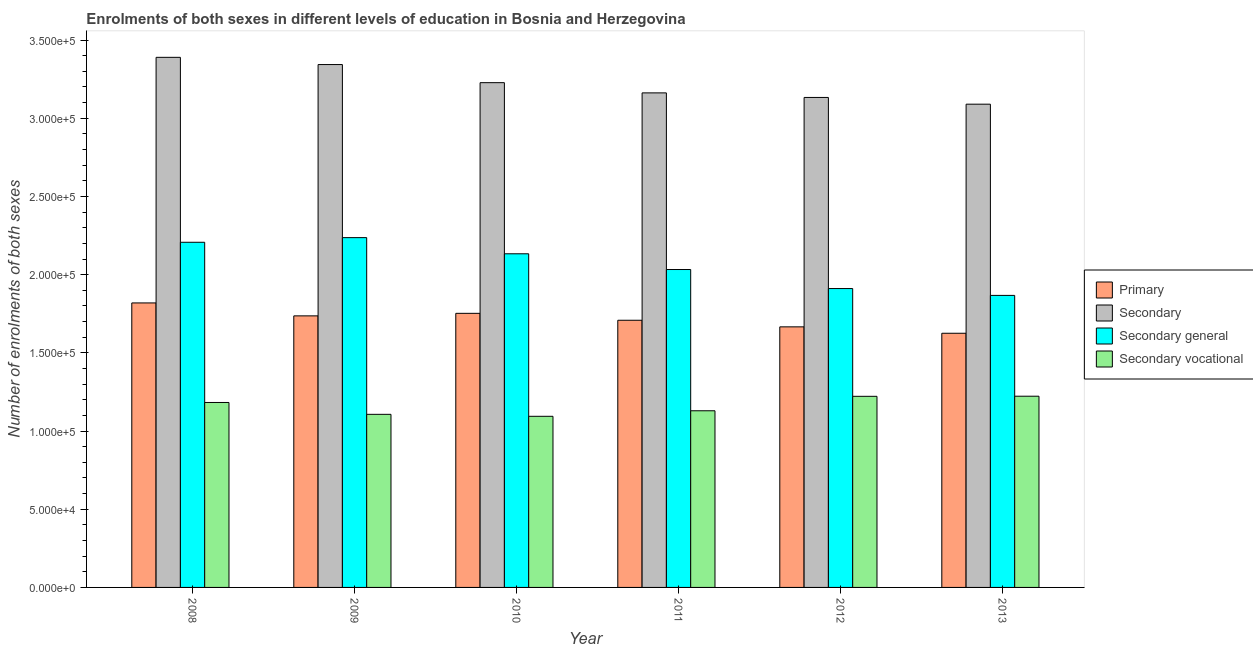How many different coloured bars are there?
Ensure brevity in your answer.  4. How many groups of bars are there?
Your response must be concise. 6. Are the number of bars per tick equal to the number of legend labels?
Offer a very short reply. Yes. Are the number of bars on each tick of the X-axis equal?
Offer a very short reply. Yes. How many bars are there on the 4th tick from the left?
Give a very brief answer. 4. What is the label of the 4th group of bars from the left?
Your answer should be compact. 2011. In how many cases, is the number of bars for a given year not equal to the number of legend labels?
Your response must be concise. 0. What is the number of enrolments in secondary general education in 2009?
Provide a short and direct response. 2.24e+05. Across all years, what is the maximum number of enrolments in primary education?
Offer a very short reply. 1.82e+05. Across all years, what is the minimum number of enrolments in secondary vocational education?
Provide a short and direct response. 1.09e+05. In which year was the number of enrolments in secondary education maximum?
Offer a terse response. 2008. In which year was the number of enrolments in primary education minimum?
Ensure brevity in your answer.  2013. What is the total number of enrolments in secondary general education in the graph?
Offer a very short reply. 1.24e+06. What is the difference between the number of enrolments in secondary education in 2008 and that in 2009?
Ensure brevity in your answer.  4616. What is the difference between the number of enrolments in secondary education in 2012 and the number of enrolments in primary education in 2009?
Offer a very short reply. -2.10e+04. What is the average number of enrolments in secondary vocational education per year?
Keep it short and to the point. 1.16e+05. In the year 2011, what is the difference between the number of enrolments in secondary general education and number of enrolments in primary education?
Your answer should be compact. 0. In how many years, is the number of enrolments in secondary vocational education greater than 260000?
Your answer should be compact. 0. What is the ratio of the number of enrolments in secondary vocational education in 2008 to that in 2010?
Keep it short and to the point. 1.08. Is the number of enrolments in secondary vocational education in 2008 less than that in 2013?
Keep it short and to the point. Yes. Is the difference between the number of enrolments in secondary general education in 2010 and 2013 greater than the difference between the number of enrolments in primary education in 2010 and 2013?
Your response must be concise. No. What is the difference between the highest and the second highest number of enrolments in primary education?
Offer a very short reply. 6646. What is the difference between the highest and the lowest number of enrolments in secondary vocational education?
Your answer should be very brief. 1.28e+04. Is it the case that in every year, the sum of the number of enrolments in secondary education and number of enrolments in secondary general education is greater than the sum of number of enrolments in primary education and number of enrolments in secondary vocational education?
Make the answer very short. Yes. What does the 2nd bar from the left in 2009 represents?
Offer a terse response. Secondary. What does the 1st bar from the right in 2010 represents?
Provide a succinct answer. Secondary vocational. Is it the case that in every year, the sum of the number of enrolments in primary education and number of enrolments in secondary education is greater than the number of enrolments in secondary general education?
Make the answer very short. Yes. How many years are there in the graph?
Your answer should be compact. 6. Does the graph contain grids?
Make the answer very short. No. How many legend labels are there?
Give a very brief answer. 4. What is the title of the graph?
Provide a short and direct response. Enrolments of both sexes in different levels of education in Bosnia and Herzegovina. Does "France" appear as one of the legend labels in the graph?
Your answer should be compact. No. What is the label or title of the Y-axis?
Keep it short and to the point. Number of enrolments of both sexes. What is the Number of enrolments of both sexes in Primary in 2008?
Offer a very short reply. 1.82e+05. What is the Number of enrolments of both sexes of Secondary in 2008?
Offer a very short reply. 3.39e+05. What is the Number of enrolments of both sexes of Secondary general in 2008?
Make the answer very short. 2.21e+05. What is the Number of enrolments of both sexes in Secondary vocational in 2008?
Your answer should be compact. 1.18e+05. What is the Number of enrolments of both sexes in Primary in 2009?
Provide a succinct answer. 1.74e+05. What is the Number of enrolments of both sexes in Secondary in 2009?
Your answer should be very brief. 3.34e+05. What is the Number of enrolments of both sexes in Secondary general in 2009?
Make the answer very short. 2.24e+05. What is the Number of enrolments of both sexes of Secondary vocational in 2009?
Your response must be concise. 1.11e+05. What is the Number of enrolments of both sexes of Primary in 2010?
Make the answer very short. 1.75e+05. What is the Number of enrolments of both sexes in Secondary in 2010?
Your answer should be compact. 3.23e+05. What is the Number of enrolments of both sexes in Secondary general in 2010?
Ensure brevity in your answer.  2.13e+05. What is the Number of enrolments of both sexes of Secondary vocational in 2010?
Make the answer very short. 1.09e+05. What is the Number of enrolments of both sexes in Primary in 2011?
Give a very brief answer. 1.71e+05. What is the Number of enrolments of both sexes of Secondary in 2011?
Provide a short and direct response. 3.16e+05. What is the Number of enrolments of both sexes in Secondary general in 2011?
Offer a terse response. 2.03e+05. What is the Number of enrolments of both sexes in Secondary vocational in 2011?
Give a very brief answer. 1.13e+05. What is the Number of enrolments of both sexes in Primary in 2012?
Give a very brief answer. 1.67e+05. What is the Number of enrolments of both sexes of Secondary in 2012?
Provide a succinct answer. 3.13e+05. What is the Number of enrolments of both sexes of Secondary general in 2012?
Keep it short and to the point. 1.91e+05. What is the Number of enrolments of both sexes of Secondary vocational in 2012?
Offer a very short reply. 1.22e+05. What is the Number of enrolments of both sexes in Primary in 2013?
Make the answer very short. 1.63e+05. What is the Number of enrolments of both sexes in Secondary in 2013?
Your answer should be very brief. 3.09e+05. What is the Number of enrolments of both sexes in Secondary general in 2013?
Provide a short and direct response. 1.87e+05. What is the Number of enrolments of both sexes in Secondary vocational in 2013?
Your answer should be very brief. 1.22e+05. Across all years, what is the maximum Number of enrolments of both sexes in Primary?
Offer a terse response. 1.82e+05. Across all years, what is the maximum Number of enrolments of both sexes of Secondary?
Keep it short and to the point. 3.39e+05. Across all years, what is the maximum Number of enrolments of both sexes of Secondary general?
Make the answer very short. 2.24e+05. Across all years, what is the maximum Number of enrolments of both sexes of Secondary vocational?
Your answer should be compact. 1.22e+05. Across all years, what is the minimum Number of enrolments of both sexes in Primary?
Keep it short and to the point. 1.63e+05. Across all years, what is the minimum Number of enrolments of both sexes of Secondary?
Give a very brief answer. 3.09e+05. Across all years, what is the minimum Number of enrolments of both sexes of Secondary general?
Offer a terse response. 1.87e+05. Across all years, what is the minimum Number of enrolments of both sexes of Secondary vocational?
Offer a very short reply. 1.09e+05. What is the total Number of enrolments of both sexes of Primary in the graph?
Provide a short and direct response. 1.03e+06. What is the total Number of enrolments of both sexes in Secondary in the graph?
Your answer should be very brief. 1.93e+06. What is the total Number of enrolments of both sexes in Secondary general in the graph?
Offer a terse response. 1.24e+06. What is the total Number of enrolments of both sexes in Secondary vocational in the graph?
Give a very brief answer. 6.96e+05. What is the difference between the Number of enrolments of both sexes in Primary in 2008 and that in 2009?
Give a very brief answer. 8270. What is the difference between the Number of enrolments of both sexes of Secondary in 2008 and that in 2009?
Provide a succinct answer. 4616. What is the difference between the Number of enrolments of both sexes of Secondary general in 2008 and that in 2009?
Make the answer very short. -2965. What is the difference between the Number of enrolments of both sexes of Secondary vocational in 2008 and that in 2009?
Offer a very short reply. 7581. What is the difference between the Number of enrolments of both sexes in Primary in 2008 and that in 2010?
Your answer should be compact. 6646. What is the difference between the Number of enrolments of both sexes of Secondary in 2008 and that in 2010?
Ensure brevity in your answer.  1.62e+04. What is the difference between the Number of enrolments of both sexes in Secondary general in 2008 and that in 2010?
Offer a very short reply. 7367. What is the difference between the Number of enrolments of both sexes of Secondary vocational in 2008 and that in 2010?
Provide a succinct answer. 8838. What is the difference between the Number of enrolments of both sexes in Primary in 2008 and that in 2011?
Ensure brevity in your answer.  1.11e+04. What is the difference between the Number of enrolments of both sexes in Secondary in 2008 and that in 2011?
Provide a short and direct response. 2.27e+04. What is the difference between the Number of enrolments of both sexes in Secondary general in 2008 and that in 2011?
Provide a short and direct response. 1.74e+04. What is the difference between the Number of enrolments of both sexes in Secondary vocational in 2008 and that in 2011?
Make the answer very short. 5300. What is the difference between the Number of enrolments of both sexes in Primary in 2008 and that in 2012?
Make the answer very short. 1.53e+04. What is the difference between the Number of enrolments of both sexes in Secondary in 2008 and that in 2012?
Provide a short and direct response. 2.56e+04. What is the difference between the Number of enrolments of both sexes of Secondary general in 2008 and that in 2012?
Offer a terse response. 2.96e+04. What is the difference between the Number of enrolments of both sexes of Secondary vocational in 2008 and that in 2012?
Offer a very short reply. -3941. What is the difference between the Number of enrolments of both sexes of Primary in 2008 and that in 2013?
Keep it short and to the point. 1.94e+04. What is the difference between the Number of enrolments of both sexes in Secondary in 2008 and that in 2013?
Provide a short and direct response. 3.00e+04. What is the difference between the Number of enrolments of both sexes in Secondary general in 2008 and that in 2013?
Your response must be concise. 3.40e+04. What is the difference between the Number of enrolments of both sexes in Secondary vocational in 2008 and that in 2013?
Provide a succinct answer. -4011. What is the difference between the Number of enrolments of both sexes in Primary in 2009 and that in 2010?
Your answer should be compact. -1624. What is the difference between the Number of enrolments of both sexes of Secondary in 2009 and that in 2010?
Provide a short and direct response. 1.16e+04. What is the difference between the Number of enrolments of both sexes of Secondary general in 2009 and that in 2010?
Offer a very short reply. 1.03e+04. What is the difference between the Number of enrolments of both sexes of Secondary vocational in 2009 and that in 2010?
Your answer should be compact. 1257. What is the difference between the Number of enrolments of both sexes of Primary in 2009 and that in 2011?
Keep it short and to the point. 2805. What is the difference between the Number of enrolments of both sexes in Secondary in 2009 and that in 2011?
Your answer should be very brief. 1.81e+04. What is the difference between the Number of enrolments of both sexes in Secondary general in 2009 and that in 2011?
Ensure brevity in your answer.  2.04e+04. What is the difference between the Number of enrolments of both sexes of Secondary vocational in 2009 and that in 2011?
Make the answer very short. -2281. What is the difference between the Number of enrolments of both sexes in Primary in 2009 and that in 2012?
Your answer should be very brief. 7027. What is the difference between the Number of enrolments of both sexes in Secondary in 2009 and that in 2012?
Give a very brief answer. 2.10e+04. What is the difference between the Number of enrolments of both sexes in Secondary general in 2009 and that in 2012?
Give a very brief answer. 3.26e+04. What is the difference between the Number of enrolments of both sexes in Secondary vocational in 2009 and that in 2012?
Provide a short and direct response. -1.15e+04. What is the difference between the Number of enrolments of both sexes of Primary in 2009 and that in 2013?
Your answer should be very brief. 1.11e+04. What is the difference between the Number of enrolments of both sexes of Secondary in 2009 and that in 2013?
Ensure brevity in your answer.  2.53e+04. What is the difference between the Number of enrolments of both sexes in Secondary general in 2009 and that in 2013?
Give a very brief answer. 3.69e+04. What is the difference between the Number of enrolments of both sexes of Secondary vocational in 2009 and that in 2013?
Give a very brief answer. -1.16e+04. What is the difference between the Number of enrolments of both sexes in Primary in 2010 and that in 2011?
Offer a very short reply. 4429. What is the difference between the Number of enrolments of both sexes of Secondary in 2010 and that in 2011?
Make the answer very short. 6525. What is the difference between the Number of enrolments of both sexes in Secondary general in 2010 and that in 2011?
Provide a succinct answer. 1.01e+04. What is the difference between the Number of enrolments of both sexes of Secondary vocational in 2010 and that in 2011?
Make the answer very short. -3538. What is the difference between the Number of enrolments of both sexes in Primary in 2010 and that in 2012?
Ensure brevity in your answer.  8651. What is the difference between the Number of enrolments of both sexes in Secondary in 2010 and that in 2012?
Give a very brief answer. 9445. What is the difference between the Number of enrolments of both sexes of Secondary general in 2010 and that in 2012?
Provide a succinct answer. 2.22e+04. What is the difference between the Number of enrolments of both sexes of Secondary vocational in 2010 and that in 2012?
Provide a succinct answer. -1.28e+04. What is the difference between the Number of enrolments of both sexes in Primary in 2010 and that in 2013?
Offer a very short reply. 1.27e+04. What is the difference between the Number of enrolments of both sexes of Secondary in 2010 and that in 2013?
Your answer should be compact. 1.38e+04. What is the difference between the Number of enrolments of both sexes in Secondary general in 2010 and that in 2013?
Your response must be concise. 2.66e+04. What is the difference between the Number of enrolments of both sexes in Secondary vocational in 2010 and that in 2013?
Make the answer very short. -1.28e+04. What is the difference between the Number of enrolments of both sexes of Primary in 2011 and that in 2012?
Give a very brief answer. 4222. What is the difference between the Number of enrolments of both sexes in Secondary in 2011 and that in 2012?
Provide a succinct answer. 2920. What is the difference between the Number of enrolments of both sexes in Secondary general in 2011 and that in 2012?
Give a very brief answer. 1.22e+04. What is the difference between the Number of enrolments of both sexes in Secondary vocational in 2011 and that in 2012?
Provide a succinct answer. -9241. What is the difference between the Number of enrolments of both sexes in Primary in 2011 and that in 2013?
Keep it short and to the point. 8314. What is the difference between the Number of enrolments of both sexes of Secondary in 2011 and that in 2013?
Your response must be concise. 7226. What is the difference between the Number of enrolments of both sexes in Secondary general in 2011 and that in 2013?
Provide a short and direct response. 1.65e+04. What is the difference between the Number of enrolments of both sexes in Secondary vocational in 2011 and that in 2013?
Provide a short and direct response. -9311. What is the difference between the Number of enrolments of both sexes of Primary in 2012 and that in 2013?
Make the answer very short. 4092. What is the difference between the Number of enrolments of both sexes in Secondary in 2012 and that in 2013?
Offer a very short reply. 4306. What is the difference between the Number of enrolments of both sexes in Secondary general in 2012 and that in 2013?
Your answer should be compact. 4376. What is the difference between the Number of enrolments of both sexes in Secondary vocational in 2012 and that in 2013?
Provide a succinct answer. -70. What is the difference between the Number of enrolments of both sexes in Primary in 2008 and the Number of enrolments of both sexes in Secondary in 2009?
Keep it short and to the point. -1.52e+05. What is the difference between the Number of enrolments of both sexes of Primary in 2008 and the Number of enrolments of both sexes of Secondary general in 2009?
Your answer should be compact. -4.18e+04. What is the difference between the Number of enrolments of both sexes in Primary in 2008 and the Number of enrolments of both sexes in Secondary vocational in 2009?
Offer a very short reply. 7.12e+04. What is the difference between the Number of enrolments of both sexes of Secondary in 2008 and the Number of enrolments of both sexes of Secondary general in 2009?
Your response must be concise. 1.15e+05. What is the difference between the Number of enrolments of both sexes of Secondary in 2008 and the Number of enrolments of both sexes of Secondary vocational in 2009?
Your response must be concise. 2.28e+05. What is the difference between the Number of enrolments of both sexes in Secondary general in 2008 and the Number of enrolments of both sexes in Secondary vocational in 2009?
Provide a short and direct response. 1.10e+05. What is the difference between the Number of enrolments of both sexes of Primary in 2008 and the Number of enrolments of both sexes of Secondary in 2010?
Your response must be concise. -1.41e+05. What is the difference between the Number of enrolments of both sexes of Primary in 2008 and the Number of enrolments of both sexes of Secondary general in 2010?
Offer a very short reply. -3.14e+04. What is the difference between the Number of enrolments of both sexes in Primary in 2008 and the Number of enrolments of both sexes in Secondary vocational in 2010?
Give a very brief answer. 7.25e+04. What is the difference between the Number of enrolments of both sexes of Secondary in 2008 and the Number of enrolments of both sexes of Secondary general in 2010?
Your response must be concise. 1.26e+05. What is the difference between the Number of enrolments of both sexes of Secondary in 2008 and the Number of enrolments of both sexes of Secondary vocational in 2010?
Give a very brief answer. 2.30e+05. What is the difference between the Number of enrolments of both sexes of Secondary general in 2008 and the Number of enrolments of both sexes of Secondary vocational in 2010?
Ensure brevity in your answer.  1.11e+05. What is the difference between the Number of enrolments of both sexes in Primary in 2008 and the Number of enrolments of both sexes in Secondary in 2011?
Your response must be concise. -1.34e+05. What is the difference between the Number of enrolments of both sexes in Primary in 2008 and the Number of enrolments of both sexes in Secondary general in 2011?
Your answer should be compact. -2.14e+04. What is the difference between the Number of enrolments of both sexes in Primary in 2008 and the Number of enrolments of both sexes in Secondary vocational in 2011?
Ensure brevity in your answer.  6.90e+04. What is the difference between the Number of enrolments of both sexes of Secondary in 2008 and the Number of enrolments of both sexes of Secondary general in 2011?
Ensure brevity in your answer.  1.36e+05. What is the difference between the Number of enrolments of both sexes in Secondary in 2008 and the Number of enrolments of both sexes in Secondary vocational in 2011?
Your answer should be compact. 2.26e+05. What is the difference between the Number of enrolments of both sexes of Secondary general in 2008 and the Number of enrolments of both sexes of Secondary vocational in 2011?
Give a very brief answer. 1.08e+05. What is the difference between the Number of enrolments of both sexes in Primary in 2008 and the Number of enrolments of both sexes in Secondary in 2012?
Make the answer very short. -1.31e+05. What is the difference between the Number of enrolments of both sexes of Primary in 2008 and the Number of enrolments of both sexes of Secondary general in 2012?
Keep it short and to the point. -9201. What is the difference between the Number of enrolments of both sexes of Primary in 2008 and the Number of enrolments of both sexes of Secondary vocational in 2012?
Your response must be concise. 5.97e+04. What is the difference between the Number of enrolments of both sexes of Secondary in 2008 and the Number of enrolments of both sexes of Secondary general in 2012?
Keep it short and to the point. 1.48e+05. What is the difference between the Number of enrolments of both sexes in Secondary in 2008 and the Number of enrolments of both sexes in Secondary vocational in 2012?
Offer a terse response. 2.17e+05. What is the difference between the Number of enrolments of both sexes of Secondary general in 2008 and the Number of enrolments of both sexes of Secondary vocational in 2012?
Offer a terse response. 9.85e+04. What is the difference between the Number of enrolments of both sexes in Primary in 2008 and the Number of enrolments of both sexes in Secondary in 2013?
Your answer should be compact. -1.27e+05. What is the difference between the Number of enrolments of both sexes in Primary in 2008 and the Number of enrolments of both sexes in Secondary general in 2013?
Provide a short and direct response. -4825. What is the difference between the Number of enrolments of both sexes of Primary in 2008 and the Number of enrolments of both sexes of Secondary vocational in 2013?
Provide a succinct answer. 5.96e+04. What is the difference between the Number of enrolments of both sexes of Secondary in 2008 and the Number of enrolments of both sexes of Secondary general in 2013?
Provide a succinct answer. 1.52e+05. What is the difference between the Number of enrolments of both sexes of Secondary in 2008 and the Number of enrolments of both sexes of Secondary vocational in 2013?
Offer a very short reply. 2.17e+05. What is the difference between the Number of enrolments of both sexes in Secondary general in 2008 and the Number of enrolments of both sexes in Secondary vocational in 2013?
Ensure brevity in your answer.  9.84e+04. What is the difference between the Number of enrolments of both sexes of Primary in 2009 and the Number of enrolments of both sexes of Secondary in 2010?
Ensure brevity in your answer.  -1.49e+05. What is the difference between the Number of enrolments of both sexes in Primary in 2009 and the Number of enrolments of both sexes in Secondary general in 2010?
Offer a terse response. -3.97e+04. What is the difference between the Number of enrolments of both sexes in Primary in 2009 and the Number of enrolments of both sexes in Secondary vocational in 2010?
Your answer should be compact. 6.42e+04. What is the difference between the Number of enrolments of both sexes of Secondary in 2009 and the Number of enrolments of both sexes of Secondary general in 2010?
Provide a succinct answer. 1.21e+05. What is the difference between the Number of enrolments of both sexes of Secondary in 2009 and the Number of enrolments of both sexes of Secondary vocational in 2010?
Provide a short and direct response. 2.25e+05. What is the difference between the Number of enrolments of both sexes in Secondary general in 2009 and the Number of enrolments of both sexes in Secondary vocational in 2010?
Make the answer very short. 1.14e+05. What is the difference between the Number of enrolments of both sexes in Primary in 2009 and the Number of enrolments of both sexes in Secondary in 2011?
Give a very brief answer. -1.43e+05. What is the difference between the Number of enrolments of both sexes in Primary in 2009 and the Number of enrolments of both sexes in Secondary general in 2011?
Make the answer very short. -2.96e+04. What is the difference between the Number of enrolments of both sexes of Primary in 2009 and the Number of enrolments of both sexes of Secondary vocational in 2011?
Provide a short and direct response. 6.07e+04. What is the difference between the Number of enrolments of both sexes in Secondary in 2009 and the Number of enrolments of both sexes in Secondary general in 2011?
Provide a succinct answer. 1.31e+05. What is the difference between the Number of enrolments of both sexes of Secondary in 2009 and the Number of enrolments of both sexes of Secondary vocational in 2011?
Provide a succinct answer. 2.21e+05. What is the difference between the Number of enrolments of both sexes in Secondary general in 2009 and the Number of enrolments of both sexes in Secondary vocational in 2011?
Your response must be concise. 1.11e+05. What is the difference between the Number of enrolments of both sexes of Primary in 2009 and the Number of enrolments of both sexes of Secondary in 2012?
Keep it short and to the point. -1.40e+05. What is the difference between the Number of enrolments of both sexes in Primary in 2009 and the Number of enrolments of both sexes in Secondary general in 2012?
Offer a terse response. -1.75e+04. What is the difference between the Number of enrolments of both sexes in Primary in 2009 and the Number of enrolments of both sexes in Secondary vocational in 2012?
Provide a short and direct response. 5.14e+04. What is the difference between the Number of enrolments of both sexes in Secondary in 2009 and the Number of enrolments of both sexes in Secondary general in 2012?
Your response must be concise. 1.43e+05. What is the difference between the Number of enrolments of both sexes in Secondary in 2009 and the Number of enrolments of both sexes in Secondary vocational in 2012?
Your response must be concise. 2.12e+05. What is the difference between the Number of enrolments of both sexes of Secondary general in 2009 and the Number of enrolments of both sexes of Secondary vocational in 2012?
Ensure brevity in your answer.  1.01e+05. What is the difference between the Number of enrolments of both sexes in Primary in 2009 and the Number of enrolments of both sexes in Secondary in 2013?
Your answer should be compact. -1.35e+05. What is the difference between the Number of enrolments of both sexes of Primary in 2009 and the Number of enrolments of both sexes of Secondary general in 2013?
Make the answer very short. -1.31e+04. What is the difference between the Number of enrolments of both sexes in Primary in 2009 and the Number of enrolments of both sexes in Secondary vocational in 2013?
Give a very brief answer. 5.14e+04. What is the difference between the Number of enrolments of both sexes in Secondary in 2009 and the Number of enrolments of both sexes in Secondary general in 2013?
Make the answer very short. 1.48e+05. What is the difference between the Number of enrolments of both sexes in Secondary in 2009 and the Number of enrolments of both sexes in Secondary vocational in 2013?
Give a very brief answer. 2.12e+05. What is the difference between the Number of enrolments of both sexes in Secondary general in 2009 and the Number of enrolments of both sexes in Secondary vocational in 2013?
Your answer should be very brief. 1.01e+05. What is the difference between the Number of enrolments of both sexes in Primary in 2010 and the Number of enrolments of both sexes in Secondary in 2011?
Make the answer very short. -1.41e+05. What is the difference between the Number of enrolments of both sexes in Primary in 2010 and the Number of enrolments of both sexes in Secondary general in 2011?
Give a very brief answer. -2.80e+04. What is the difference between the Number of enrolments of both sexes of Primary in 2010 and the Number of enrolments of both sexes of Secondary vocational in 2011?
Make the answer very short. 6.23e+04. What is the difference between the Number of enrolments of both sexes in Secondary in 2010 and the Number of enrolments of both sexes in Secondary general in 2011?
Your answer should be very brief. 1.19e+05. What is the difference between the Number of enrolments of both sexes in Secondary in 2010 and the Number of enrolments of both sexes in Secondary vocational in 2011?
Your answer should be compact. 2.10e+05. What is the difference between the Number of enrolments of both sexes in Secondary general in 2010 and the Number of enrolments of both sexes in Secondary vocational in 2011?
Your response must be concise. 1.00e+05. What is the difference between the Number of enrolments of both sexes of Primary in 2010 and the Number of enrolments of both sexes of Secondary in 2012?
Keep it short and to the point. -1.38e+05. What is the difference between the Number of enrolments of both sexes of Primary in 2010 and the Number of enrolments of both sexes of Secondary general in 2012?
Your answer should be compact. -1.58e+04. What is the difference between the Number of enrolments of both sexes in Primary in 2010 and the Number of enrolments of both sexes in Secondary vocational in 2012?
Keep it short and to the point. 5.31e+04. What is the difference between the Number of enrolments of both sexes in Secondary in 2010 and the Number of enrolments of both sexes in Secondary general in 2012?
Make the answer very short. 1.32e+05. What is the difference between the Number of enrolments of both sexes of Secondary in 2010 and the Number of enrolments of both sexes of Secondary vocational in 2012?
Provide a succinct answer. 2.01e+05. What is the difference between the Number of enrolments of both sexes of Secondary general in 2010 and the Number of enrolments of both sexes of Secondary vocational in 2012?
Ensure brevity in your answer.  9.11e+04. What is the difference between the Number of enrolments of both sexes in Primary in 2010 and the Number of enrolments of both sexes in Secondary in 2013?
Ensure brevity in your answer.  -1.34e+05. What is the difference between the Number of enrolments of both sexes in Primary in 2010 and the Number of enrolments of both sexes in Secondary general in 2013?
Your answer should be compact. -1.15e+04. What is the difference between the Number of enrolments of both sexes in Primary in 2010 and the Number of enrolments of both sexes in Secondary vocational in 2013?
Keep it short and to the point. 5.30e+04. What is the difference between the Number of enrolments of both sexes of Secondary in 2010 and the Number of enrolments of both sexes of Secondary general in 2013?
Make the answer very short. 1.36e+05. What is the difference between the Number of enrolments of both sexes of Secondary in 2010 and the Number of enrolments of both sexes of Secondary vocational in 2013?
Provide a succinct answer. 2.00e+05. What is the difference between the Number of enrolments of both sexes of Secondary general in 2010 and the Number of enrolments of both sexes of Secondary vocational in 2013?
Make the answer very short. 9.11e+04. What is the difference between the Number of enrolments of both sexes of Primary in 2011 and the Number of enrolments of both sexes of Secondary in 2012?
Your answer should be compact. -1.42e+05. What is the difference between the Number of enrolments of both sexes of Primary in 2011 and the Number of enrolments of both sexes of Secondary general in 2012?
Provide a short and direct response. -2.03e+04. What is the difference between the Number of enrolments of both sexes of Primary in 2011 and the Number of enrolments of both sexes of Secondary vocational in 2012?
Provide a succinct answer. 4.86e+04. What is the difference between the Number of enrolments of both sexes in Secondary in 2011 and the Number of enrolments of both sexes in Secondary general in 2012?
Provide a short and direct response. 1.25e+05. What is the difference between the Number of enrolments of both sexes of Secondary in 2011 and the Number of enrolments of both sexes of Secondary vocational in 2012?
Provide a short and direct response. 1.94e+05. What is the difference between the Number of enrolments of both sexes in Secondary general in 2011 and the Number of enrolments of both sexes in Secondary vocational in 2012?
Your answer should be compact. 8.11e+04. What is the difference between the Number of enrolments of both sexes in Primary in 2011 and the Number of enrolments of both sexes in Secondary in 2013?
Offer a terse response. -1.38e+05. What is the difference between the Number of enrolments of both sexes of Primary in 2011 and the Number of enrolments of both sexes of Secondary general in 2013?
Provide a succinct answer. -1.59e+04. What is the difference between the Number of enrolments of both sexes in Primary in 2011 and the Number of enrolments of both sexes in Secondary vocational in 2013?
Make the answer very short. 4.86e+04. What is the difference between the Number of enrolments of both sexes in Secondary in 2011 and the Number of enrolments of both sexes in Secondary general in 2013?
Give a very brief answer. 1.29e+05. What is the difference between the Number of enrolments of both sexes of Secondary in 2011 and the Number of enrolments of both sexes of Secondary vocational in 2013?
Provide a succinct answer. 1.94e+05. What is the difference between the Number of enrolments of both sexes of Secondary general in 2011 and the Number of enrolments of both sexes of Secondary vocational in 2013?
Keep it short and to the point. 8.10e+04. What is the difference between the Number of enrolments of both sexes of Primary in 2012 and the Number of enrolments of both sexes of Secondary in 2013?
Keep it short and to the point. -1.42e+05. What is the difference between the Number of enrolments of both sexes in Primary in 2012 and the Number of enrolments of both sexes in Secondary general in 2013?
Make the answer very short. -2.01e+04. What is the difference between the Number of enrolments of both sexes in Primary in 2012 and the Number of enrolments of both sexes in Secondary vocational in 2013?
Your response must be concise. 4.43e+04. What is the difference between the Number of enrolments of both sexes in Secondary in 2012 and the Number of enrolments of both sexes in Secondary general in 2013?
Offer a very short reply. 1.27e+05. What is the difference between the Number of enrolments of both sexes in Secondary in 2012 and the Number of enrolments of both sexes in Secondary vocational in 2013?
Your answer should be very brief. 1.91e+05. What is the difference between the Number of enrolments of both sexes in Secondary general in 2012 and the Number of enrolments of both sexes in Secondary vocational in 2013?
Offer a very short reply. 6.88e+04. What is the average Number of enrolments of both sexes of Primary per year?
Keep it short and to the point. 1.72e+05. What is the average Number of enrolments of both sexes of Secondary per year?
Make the answer very short. 3.22e+05. What is the average Number of enrolments of both sexes of Secondary general per year?
Make the answer very short. 2.06e+05. What is the average Number of enrolments of both sexes in Secondary vocational per year?
Your answer should be compact. 1.16e+05. In the year 2008, what is the difference between the Number of enrolments of both sexes of Primary and Number of enrolments of both sexes of Secondary?
Your response must be concise. -1.57e+05. In the year 2008, what is the difference between the Number of enrolments of both sexes in Primary and Number of enrolments of both sexes in Secondary general?
Make the answer very short. -3.88e+04. In the year 2008, what is the difference between the Number of enrolments of both sexes of Primary and Number of enrolments of both sexes of Secondary vocational?
Your response must be concise. 6.37e+04. In the year 2008, what is the difference between the Number of enrolments of both sexes of Secondary and Number of enrolments of both sexes of Secondary general?
Your answer should be compact. 1.18e+05. In the year 2008, what is the difference between the Number of enrolments of both sexes of Secondary and Number of enrolments of both sexes of Secondary vocational?
Your response must be concise. 2.21e+05. In the year 2008, what is the difference between the Number of enrolments of both sexes of Secondary general and Number of enrolments of both sexes of Secondary vocational?
Give a very brief answer. 1.02e+05. In the year 2009, what is the difference between the Number of enrolments of both sexes of Primary and Number of enrolments of both sexes of Secondary?
Offer a terse response. -1.61e+05. In the year 2009, what is the difference between the Number of enrolments of both sexes in Primary and Number of enrolments of both sexes in Secondary general?
Provide a short and direct response. -5.00e+04. In the year 2009, what is the difference between the Number of enrolments of both sexes in Primary and Number of enrolments of both sexes in Secondary vocational?
Offer a very short reply. 6.30e+04. In the year 2009, what is the difference between the Number of enrolments of both sexes of Secondary and Number of enrolments of both sexes of Secondary general?
Give a very brief answer. 1.11e+05. In the year 2009, what is the difference between the Number of enrolments of both sexes in Secondary and Number of enrolments of both sexes in Secondary vocational?
Provide a succinct answer. 2.24e+05. In the year 2009, what is the difference between the Number of enrolments of both sexes of Secondary general and Number of enrolments of both sexes of Secondary vocational?
Offer a terse response. 1.13e+05. In the year 2010, what is the difference between the Number of enrolments of both sexes in Primary and Number of enrolments of both sexes in Secondary?
Provide a succinct answer. -1.47e+05. In the year 2010, what is the difference between the Number of enrolments of both sexes of Primary and Number of enrolments of both sexes of Secondary general?
Offer a terse response. -3.81e+04. In the year 2010, what is the difference between the Number of enrolments of both sexes in Primary and Number of enrolments of both sexes in Secondary vocational?
Your answer should be very brief. 6.58e+04. In the year 2010, what is the difference between the Number of enrolments of both sexes in Secondary and Number of enrolments of both sexes in Secondary general?
Make the answer very short. 1.09e+05. In the year 2010, what is the difference between the Number of enrolments of both sexes in Secondary and Number of enrolments of both sexes in Secondary vocational?
Your answer should be compact. 2.13e+05. In the year 2010, what is the difference between the Number of enrolments of both sexes of Secondary general and Number of enrolments of both sexes of Secondary vocational?
Ensure brevity in your answer.  1.04e+05. In the year 2011, what is the difference between the Number of enrolments of both sexes of Primary and Number of enrolments of both sexes of Secondary?
Give a very brief answer. -1.45e+05. In the year 2011, what is the difference between the Number of enrolments of both sexes of Primary and Number of enrolments of both sexes of Secondary general?
Offer a terse response. -3.24e+04. In the year 2011, what is the difference between the Number of enrolments of both sexes of Primary and Number of enrolments of both sexes of Secondary vocational?
Keep it short and to the point. 5.79e+04. In the year 2011, what is the difference between the Number of enrolments of both sexes in Secondary and Number of enrolments of both sexes in Secondary general?
Provide a short and direct response. 1.13e+05. In the year 2011, what is the difference between the Number of enrolments of both sexes in Secondary and Number of enrolments of both sexes in Secondary vocational?
Your answer should be very brief. 2.03e+05. In the year 2011, what is the difference between the Number of enrolments of both sexes in Secondary general and Number of enrolments of both sexes in Secondary vocational?
Your answer should be very brief. 9.03e+04. In the year 2012, what is the difference between the Number of enrolments of both sexes of Primary and Number of enrolments of both sexes of Secondary?
Your response must be concise. -1.47e+05. In the year 2012, what is the difference between the Number of enrolments of both sexes of Primary and Number of enrolments of both sexes of Secondary general?
Give a very brief answer. -2.45e+04. In the year 2012, what is the difference between the Number of enrolments of both sexes in Primary and Number of enrolments of both sexes in Secondary vocational?
Provide a succinct answer. 4.44e+04. In the year 2012, what is the difference between the Number of enrolments of both sexes in Secondary and Number of enrolments of both sexes in Secondary general?
Your answer should be very brief. 1.22e+05. In the year 2012, what is the difference between the Number of enrolments of both sexes of Secondary and Number of enrolments of both sexes of Secondary vocational?
Keep it short and to the point. 1.91e+05. In the year 2012, what is the difference between the Number of enrolments of both sexes of Secondary general and Number of enrolments of both sexes of Secondary vocational?
Offer a very short reply. 6.89e+04. In the year 2013, what is the difference between the Number of enrolments of both sexes in Primary and Number of enrolments of both sexes in Secondary?
Provide a short and direct response. -1.46e+05. In the year 2013, what is the difference between the Number of enrolments of both sexes of Primary and Number of enrolments of both sexes of Secondary general?
Give a very brief answer. -2.42e+04. In the year 2013, what is the difference between the Number of enrolments of both sexes in Primary and Number of enrolments of both sexes in Secondary vocational?
Offer a very short reply. 4.03e+04. In the year 2013, what is the difference between the Number of enrolments of both sexes of Secondary and Number of enrolments of both sexes of Secondary general?
Offer a terse response. 1.22e+05. In the year 2013, what is the difference between the Number of enrolments of both sexes in Secondary and Number of enrolments of both sexes in Secondary vocational?
Offer a terse response. 1.87e+05. In the year 2013, what is the difference between the Number of enrolments of both sexes of Secondary general and Number of enrolments of both sexes of Secondary vocational?
Keep it short and to the point. 6.45e+04. What is the ratio of the Number of enrolments of both sexes in Primary in 2008 to that in 2009?
Your answer should be very brief. 1.05. What is the ratio of the Number of enrolments of both sexes in Secondary in 2008 to that in 2009?
Give a very brief answer. 1.01. What is the ratio of the Number of enrolments of both sexes in Secondary general in 2008 to that in 2009?
Keep it short and to the point. 0.99. What is the ratio of the Number of enrolments of both sexes in Secondary vocational in 2008 to that in 2009?
Provide a short and direct response. 1.07. What is the ratio of the Number of enrolments of both sexes in Primary in 2008 to that in 2010?
Your response must be concise. 1.04. What is the ratio of the Number of enrolments of both sexes of Secondary in 2008 to that in 2010?
Provide a succinct answer. 1.05. What is the ratio of the Number of enrolments of both sexes in Secondary general in 2008 to that in 2010?
Keep it short and to the point. 1.03. What is the ratio of the Number of enrolments of both sexes in Secondary vocational in 2008 to that in 2010?
Ensure brevity in your answer.  1.08. What is the ratio of the Number of enrolments of both sexes of Primary in 2008 to that in 2011?
Provide a short and direct response. 1.06. What is the ratio of the Number of enrolments of both sexes of Secondary in 2008 to that in 2011?
Your answer should be very brief. 1.07. What is the ratio of the Number of enrolments of both sexes of Secondary general in 2008 to that in 2011?
Keep it short and to the point. 1.09. What is the ratio of the Number of enrolments of both sexes in Secondary vocational in 2008 to that in 2011?
Provide a succinct answer. 1.05. What is the ratio of the Number of enrolments of both sexes of Primary in 2008 to that in 2012?
Ensure brevity in your answer.  1.09. What is the ratio of the Number of enrolments of both sexes in Secondary in 2008 to that in 2012?
Offer a terse response. 1.08. What is the ratio of the Number of enrolments of both sexes in Secondary general in 2008 to that in 2012?
Make the answer very short. 1.15. What is the ratio of the Number of enrolments of both sexes of Secondary vocational in 2008 to that in 2012?
Keep it short and to the point. 0.97. What is the ratio of the Number of enrolments of both sexes of Primary in 2008 to that in 2013?
Provide a short and direct response. 1.12. What is the ratio of the Number of enrolments of both sexes in Secondary in 2008 to that in 2013?
Make the answer very short. 1.1. What is the ratio of the Number of enrolments of both sexes of Secondary general in 2008 to that in 2013?
Offer a very short reply. 1.18. What is the ratio of the Number of enrolments of both sexes in Secondary vocational in 2008 to that in 2013?
Give a very brief answer. 0.97. What is the ratio of the Number of enrolments of both sexes of Primary in 2009 to that in 2010?
Provide a short and direct response. 0.99. What is the ratio of the Number of enrolments of both sexes of Secondary in 2009 to that in 2010?
Your answer should be very brief. 1.04. What is the ratio of the Number of enrolments of both sexes in Secondary general in 2009 to that in 2010?
Keep it short and to the point. 1.05. What is the ratio of the Number of enrolments of both sexes in Secondary vocational in 2009 to that in 2010?
Offer a very short reply. 1.01. What is the ratio of the Number of enrolments of both sexes of Primary in 2009 to that in 2011?
Offer a terse response. 1.02. What is the ratio of the Number of enrolments of both sexes in Secondary in 2009 to that in 2011?
Provide a succinct answer. 1.06. What is the ratio of the Number of enrolments of both sexes in Secondary general in 2009 to that in 2011?
Keep it short and to the point. 1.1. What is the ratio of the Number of enrolments of both sexes of Secondary vocational in 2009 to that in 2011?
Your answer should be compact. 0.98. What is the ratio of the Number of enrolments of both sexes in Primary in 2009 to that in 2012?
Offer a terse response. 1.04. What is the ratio of the Number of enrolments of both sexes of Secondary in 2009 to that in 2012?
Offer a terse response. 1.07. What is the ratio of the Number of enrolments of both sexes in Secondary general in 2009 to that in 2012?
Make the answer very short. 1.17. What is the ratio of the Number of enrolments of both sexes of Secondary vocational in 2009 to that in 2012?
Offer a very short reply. 0.91. What is the ratio of the Number of enrolments of both sexes of Primary in 2009 to that in 2013?
Your answer should be compact. 1.07. What is the ratio of the Number of enrolments of both sexes in Secondary in 2009 to that in 2013?
Make the answer very short. 1.08. What is the ratio of the Number of enrolments of both sexes in Secondary general in 2009 to that in 2013?
Your answer should be very brief. 1.2. What is the ratio of the Number of enrolments of both sexes in Secondary vocational in 2009 to that in 2013?
Your response must be concise. 0.91. What is the ratio of the Number of enrolments of both sexes in Primary in 2010 to that in 2011?
Offer a very short reply. 1.03. What is the ratio of the Number of enrolments of both sexes of Secondary in 2010 to that in 2011?
Your response must be concise. 1.02. What is the ratio of the Number of enrolments of both sexes in Secondary general in 2010 to that in 2011?
Your answer should be very brief. 1.05. What is the ratio of the Number of enrolments of both sexes in Secondary vocational in 2010 to that in 2011?
Offer a very short reply. 0.97. What is the ratio of the Number of enrolments of both sexes of Primary in 2010 to that in 2012?
Your answer should be compact. 1.05. What is the ratio of the Number of enrolments of both sexes in Secondary in 2010 to that in 2012?
Keep it short and to the point. 1.03. What is the ratio of the Number of enrolments of both sexes in Secondary general in 2010 to that in 2012?
Your response must be concise. 1.12. What is the ratio of the Number of enrolments of both sexes of Secondary vocational in 2010 to that in 2012?
Give a very brief answer. 0.9. What is the ratio of the Number of enrolments of both sexes in Primary in 2010 to that in 2013?
Provide a short and direct response. 1.08. What is the ratio of the Number of enrolments of both sexes in Secondary in 2010 to that in 2013?
Your response must be concise. 1.04. What is the ratio of the Number of enrolments of both sexes of Secondary general in 2010 to that in 2013?
Provide a succinct answer. 1.14. What is the ratio of the Number of enrolments of both sexes in Secondary vocational in 2010 to that in 2013?
Offer a terse response. 0.89. What is the ratio of the Number of enrolments of both sexes in Primary in 2011 to that in 2012?
Provide a succinct answer. 1.03. What is the ratio of the Number of enrolments of both sexes in Secondary in 2011 to that in 2012?
Make the answer very short. 1.01. What is the ratio of the Number of enrolments of both sexes in Secondary general in 2011 to that in 2012?
Offer a terse response. 1.06. What is the ratio of the Number of enrolments of both sexes of Secondary vocational in 2011 to that in 2012?
Your response must be concise. 0.92. What is the ratio of the Number of enrolments of both sexes of Primary in 2011 to that in 2013?
Keep it short and to the point. 1.05. What is the ratio of the Number of enrolments of both sexes in Secondary in 2011 to that in 2013?
Keep it short and to the point. 1.02. What is the ratio of the Number of enrolments of both sexes in Secondary general in 2011 to that in 2013?
Provide a short and direct response. 1.09. What is the ratio of the Number of enrolments of both sexes in Secondary vocational in 2011 to that in 2013?
Provide a short and direct response. 0.92. What is the ratio of the Number of enrolments of both sexes of Primary in 2012 to that in 2013?
Ensure brevity in your answer.  1.03. What is the ratio of the Number of enrolments of both sexes in Secondary in 2012 to that in 2013?
Give a very brief answer. 1.01. What is the ratio of the Number of enrolments of both sexes of Secondary general in 2012 to that in 2013?
Offer a very short reply. 1.02. What is the difference between the highest and the second highest Number of enrolments of both sexes in Primary?
Give a very brief answer. 6646. What is the difference between the highest and the second highest Number of enrolments of both sexes in Secondary?
Your answer should be compact. 4616. What is the difference between the highest and the second highest Number of enrolments of both sexes of Secondary general?
Offer a terse response. 2965. What is the difference between the highest and the second highest Number of enrolments of both sexes in Secondary vocational?
Make the answer very short. 70. What is the difference between the highest and the lowest Number of enrolments of both sexes of Primary?
Give a very brief answer. 1.94e+04. What is the difference between the highest and the lowest Number of enrolments of both sexes of Secondary?
Offer a very short reply. 3.00e+04. What is the difference between the highest and the lowest Number of enrolments of both sexes of Secondary general?
Your response must be concise. 3.69e+04. What is the difference between the highest and the lowest Number of enrolments of both sexes in Secondary vocational?
Offer a very short reply. 1.28e+04. 